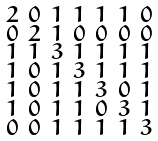<formula> <loc_0><loc_0><loc_500><loc_500>\begin{smallmatrix} 2 & 0 & 1 & 1 & 1 & 1 & 0 \\ 0 & 2 & 1 & 0 & 0 & 0 & 0 \\ 1 & 1 & 3 & 1 & 1 & 1 & 1 \\ 1 & 0 & 1 & 3 & 1 & 1 & 1 \\ 1 & 0 & 1 & 1 & 3 & 0 & 1 \\ 1 & 0 & 1 & 1 & 0 & 3 & 1 \\ 0 & 0 & 1 & 1 & 1 & 1 & 3 \end{smallmatrix}</formula> 